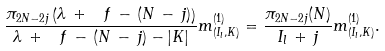<formula> <loc_0><loc_0><loc_500><loc_500>\frac { \pi _ { 2 N - 2 j } \left ( \lambda \, + \, \ f \, - \, ( N \, - \, j ) \right ) } { \lambda \, + \, \ f \, - \, ( N \, - \, j ) - | K | } m _ { ( I _ { l } , K ) } ^ { ( 1 ) } = \frac { \pi _ { 2 N - 2 j } ( N ) } { I _ { l } \, + \, j } m _ { ( I _ { l } , K ) } ^ { ( 1 ) } .</formula> 